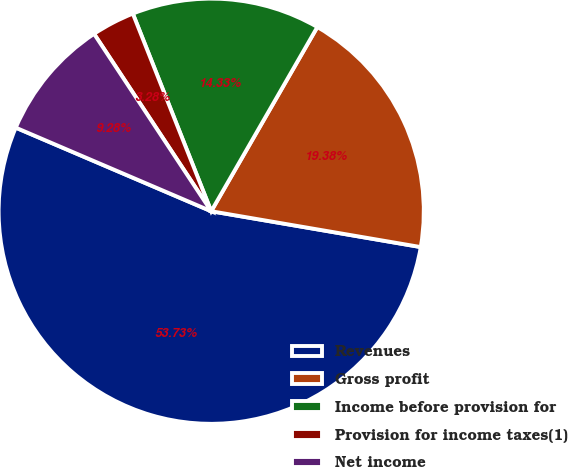<chart> <loc_0><loc_0><loc_500><loc_500><pie_chart><fcel>Revenues<fcel>Gross profit<fcel>Income before provision for<fcel>Provision for income taxes(1)<fcel>Net income<nl><fcel>53.74%<fcel>19.38%<fcel>14.33%<fcel>3.28%<fcel>9.28%<nl></chart> 